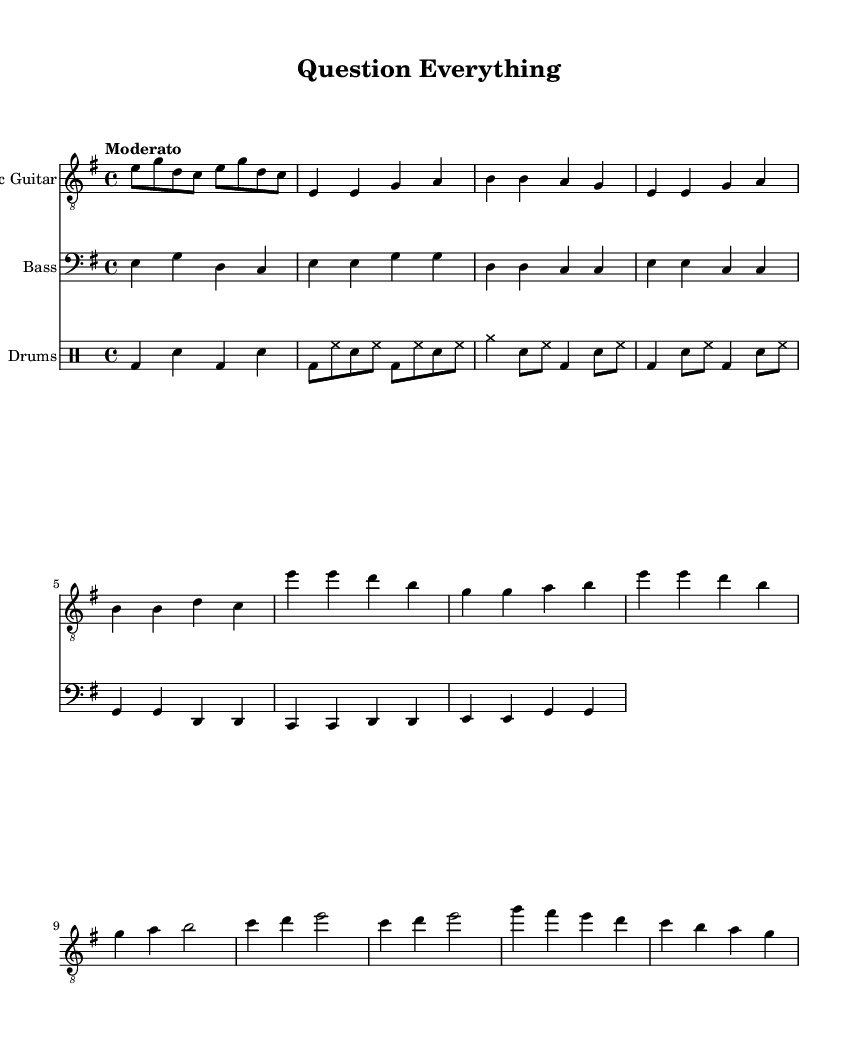What is the key signature of this music? The key signature indicates a key of E minor, which typically has one sharp (F#) when you see E minor being used in sheet music. The presence of E and other natural notes without any accidentals further confirms this.
Answer: E minor What is the time signature of this music? The time signature displayed at the beginning of the score shows that it is in 4/4, which means there are four beats per measure and the quarter note gets one beat. This can often be found next to the key signature.
Answer: 4/4 What tempo marking is indicated in this music? The tempo marking "Moderato" suggests a moderate speed for the piece, generally in the range of 100-120 beats per minute, which encourages a balanced pace. This indicates the musical feel and can be found in the header of the music.
Answer: Moderato How many measures are in the verse section? By counting the individual measures listed in the verse section, there are 4 distinct measures indicated. Each measure contains a specific grouping of notes, which can be visually counted.
Answer: 4 What is the last note of the chorus section? The last note of the chorus section is a half note represented by "b2", which is distinguished by the number indicating it is held for two beats. This is observed at the end of the chorus notation.
Answer: b2 How many distinct sections are there in this music? The music consists of four distinct sections: Intro, Verse, Chorus, and Bridge. Each section is marked and contributes to the overall structure, which can be observed by identifying the different parts in the score.
Answer: 4 